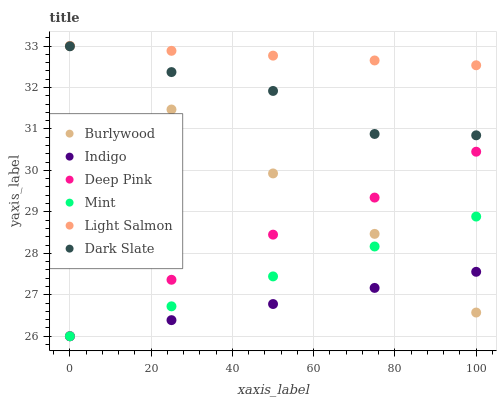Does Indigo have the minimum area under the curve?
Answer yes or no. Yes. Does Light Salmon have the maximum area under the curve?
Answer yes or no. Yes. Does Deep Pink have the minimum area under the curve?
Answer yes or no. No. Does Deep Pink have the maximum area under the curve?
Answer yes or no. No. Is Mint the smoothest?
Answer yes or no. Yes. Is Dark Slate the roughest?
Answer yes or no. Yes. Is Deep Pink the smoothest?
Answer yes or no. No. Is Deep Pink the roughest?
Answer yes or no. No. Does Deep Pink have the lowest value?
Answer yes or no. Yes. Does Burlywood have the lowest value?
Answer yes or no. No. Does Burlywood have the highest value?
Answer yes or no. Yes. Does Deep Pink have the highest value?
Answer yes or no. No. Is Deep Pink less than Dark Slate?
Answer yes or no. Yes. Is Dark Slate greater than Indigo?
Answer yes or no. Yes. Does Light Salmon intersect Burlywood?
Answer yes or no. Yes. Is Light Salmon less than Burlywood?
Answer yes or no. No. Is Light Salmon greater than Burlywood?
Answer yes or no. No. Does Deep Pink intersect Dark Slate?
Answer yes or no. No. 